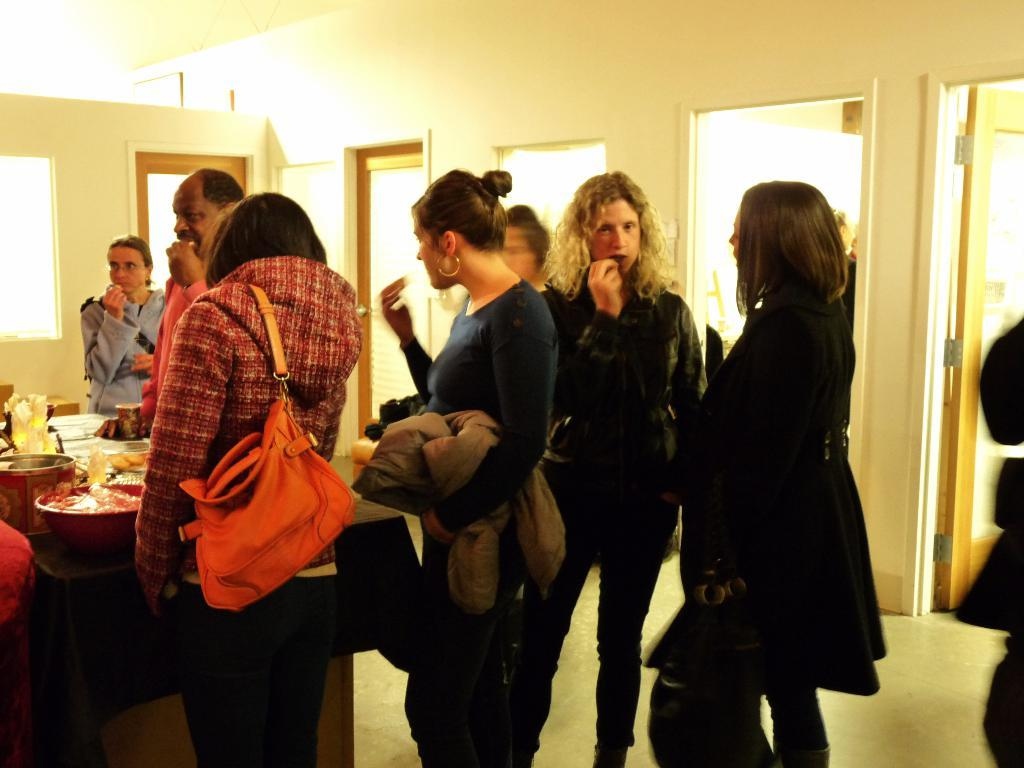How many people are in the image? There is a group of people in the image. What are the people in the image doing? The people are standing together. What can be seen on the table in the image? The table is served with food items. What architectural feature is visible in the background of the image? There are doors on the wall in the background of the image. What type of disease is being treated by the people in the image? There is no indication of any disease or medical treatment in the image; it simply shows a group of people standing together. What type of crate is visible in the image? There is no crate present in the image. 